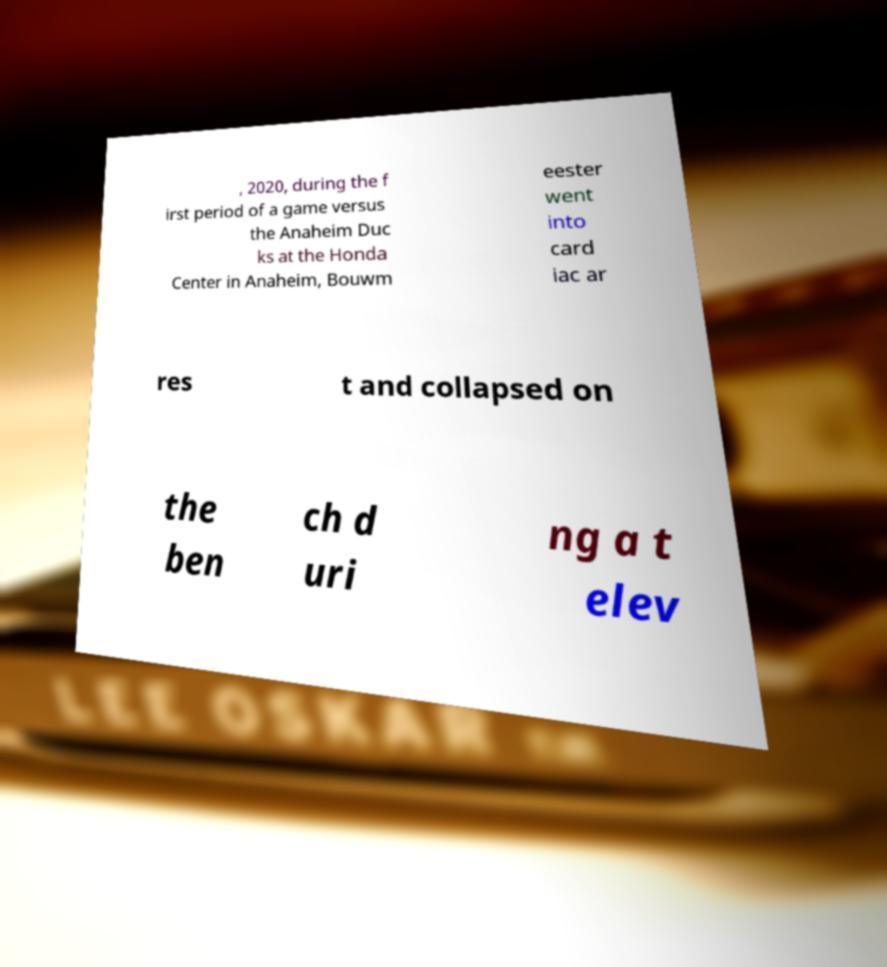Could you assist in decoding the text presented in this image and type it out clearly? , 2020, during the f irst period of a game versus the Anaheim Duc ks at the Honda Center in Anaheim, Bouwm eester went into card iac ar res t and collapsed on the ben ch d uri ng a t elev 